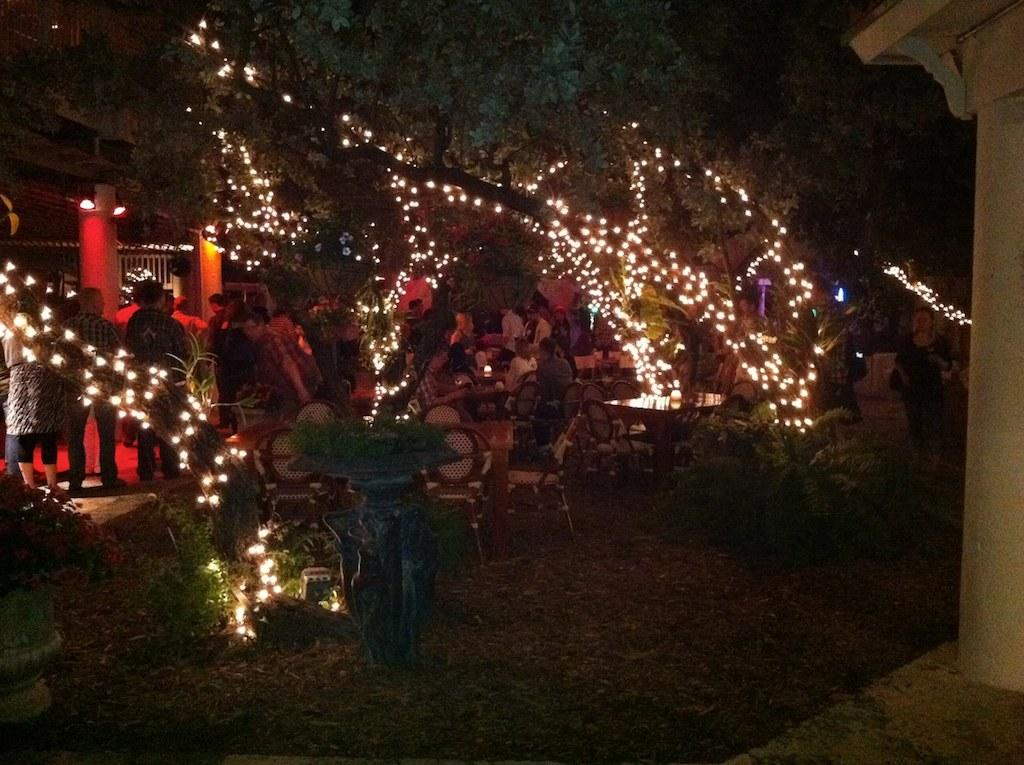How many people are present in the image? There are many people in the image. What are the people wearing? The people are wearing clothes. What are the people doing in the image? Some people are standing, while others are sitting on chairs. What type of vegetation can be seen in the image? There are trees and a plant in the image. What architectural features are present in the image? There is a fence and a pillar in the image. What can be seen in the image that provides illumination? There are lights in the image. What type of work is being done by the force in the image? There is no force or work being done in the image; it features people, trees, a plant, a fence, a pillar, and lights. What type of treatment is being administered to the people in the image? There is no treatment being administered to the people in the image; they are simply standing or sitting. 